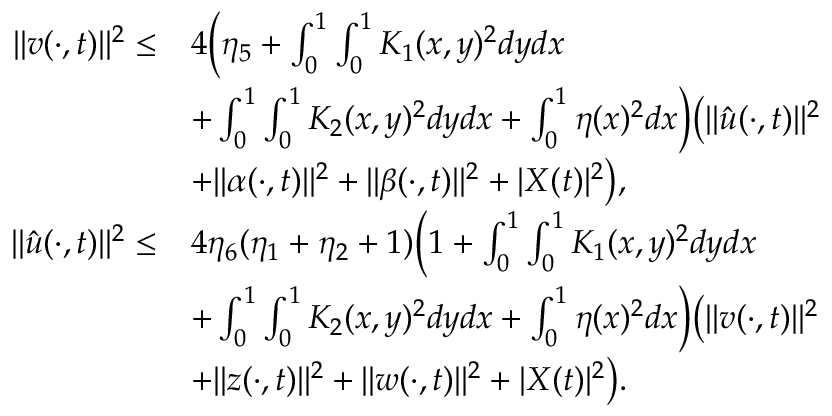<formula> <loc_0><loc_0><loc_500><loc_500>\begin{array} { r l } { | | v ( \cdot , t ) | | ^ { 2 } \leq } & { 4 \left ( \eta _ { 5 } + \int _ { 0 } ^ { 1 } \int _ { 0 } ^ { 1 } K _ { 1 } ( x , y ) ^ { 2 } d y d x } \\ & { + \int _ { 0 } ^ { 1 } \int _ { 0 } ^ { 1 } K _ { 2 } ( x , y ) ^ { 2 } d y d x + \int _ { 0 } ^ { 1 } \eta ( x ) ^ { 2 } d x \right ) \left ( \| \hat { u } ( \cdot , t ) \| ^ { 2 } } \\ & { + | | \alpha ( \cdot , t ) | | ^ { 2 } + | | \beta ( \cdot , t ) | | ^ { 2 } + | { X } ( t ) | ^ { 2 } \right ) , } \\ { | | \hat { u } ( \cdot , t ) | | ^ { 2 } \leq } & { 4 \eta _ { 6 } ( \eta _ { 1 } + \eta _ { 2 } + 1 ) \left ( 1 + \int _ { 0 } ^ { 1 } \int _ { 0 } ^ { 1 } K _ { 1 } ( x , y ) ^ { 2 } d y d x } \\ & { + \int _ { 0 } ^ { 1 } \int _ { 0 } ^ { 1 } K _ { 2 } ( x , y ) ^ { 2 } d y d x + \int _ { 0 } ^ { 1 } \eta ( x ) ^ { 2 } d x \right ) \left ( | | v ( \cdot , t ) | | ^ { 2 } } \\ & { + \| z ( \cdot , t ) \| ^ { 2 } + \| w ( \cdot , t ) \| ^ { 2 } + | X ( t ) | ^ { 2 } \right ) . } \end{array}</formula> 